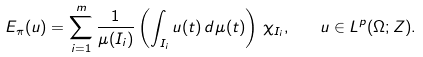Convert formula to latex. <formula><loc_0><loc_0><loc_500><loc_500>E _ { \pi } ( u ) = \sum _ { i = 1 } ^ { m } \frac { 1 } { \mu ( I _ { i } ) } \left ( \int _ { I _ { i } } u ( t ) \, d \mu ( t ) \right ) \, \chi _ { I _ { i } } , \quad u \in L ^ { p } ( \Omega ; Z ) .</formula> 